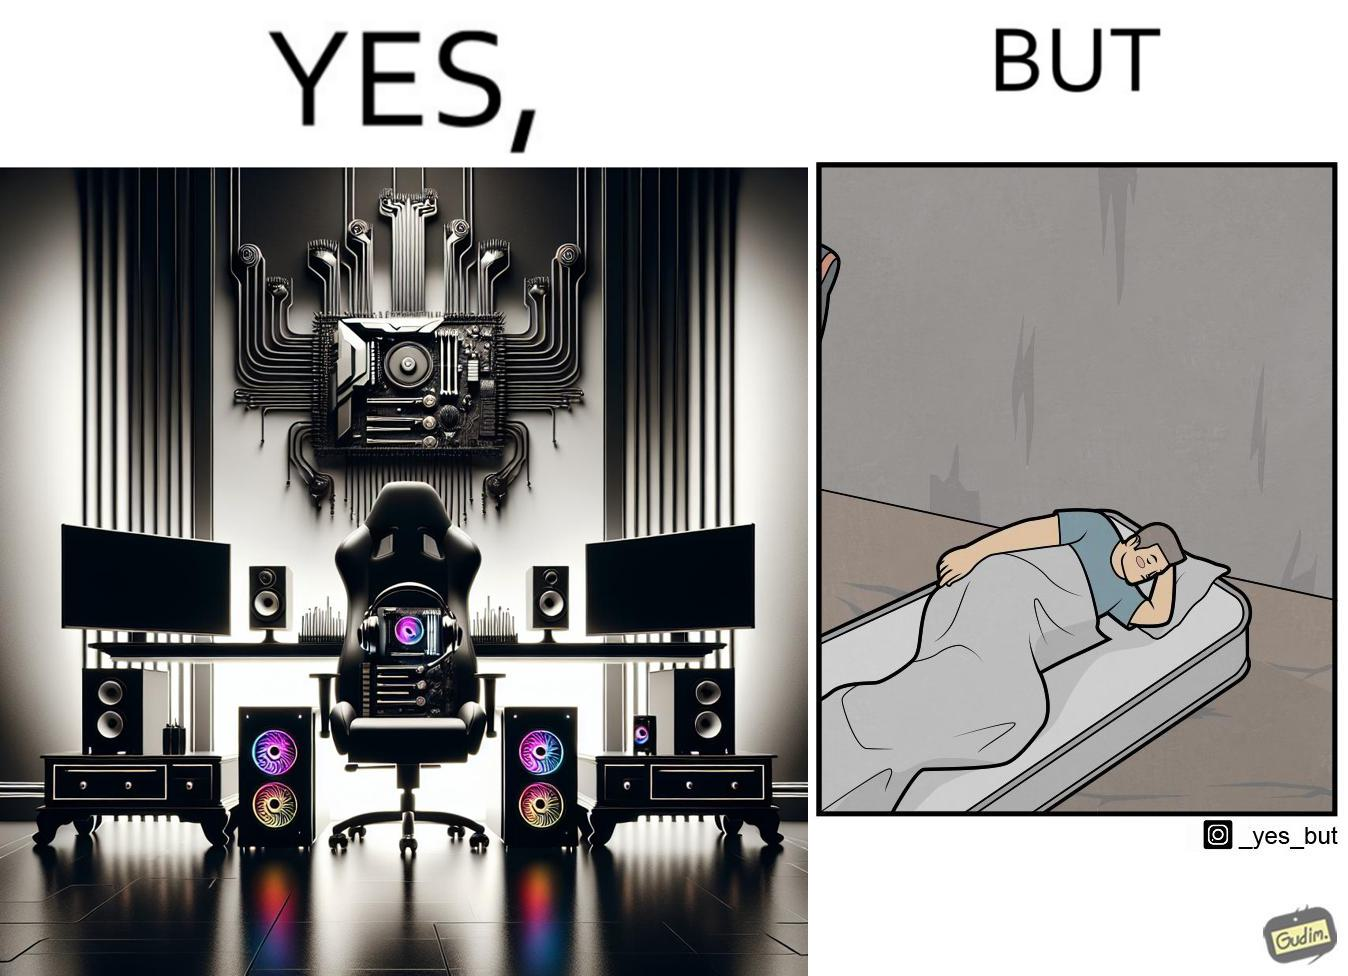Describe what you see in this image. The image is funny because the person has a lot of furniture for his computer but none for himself. 